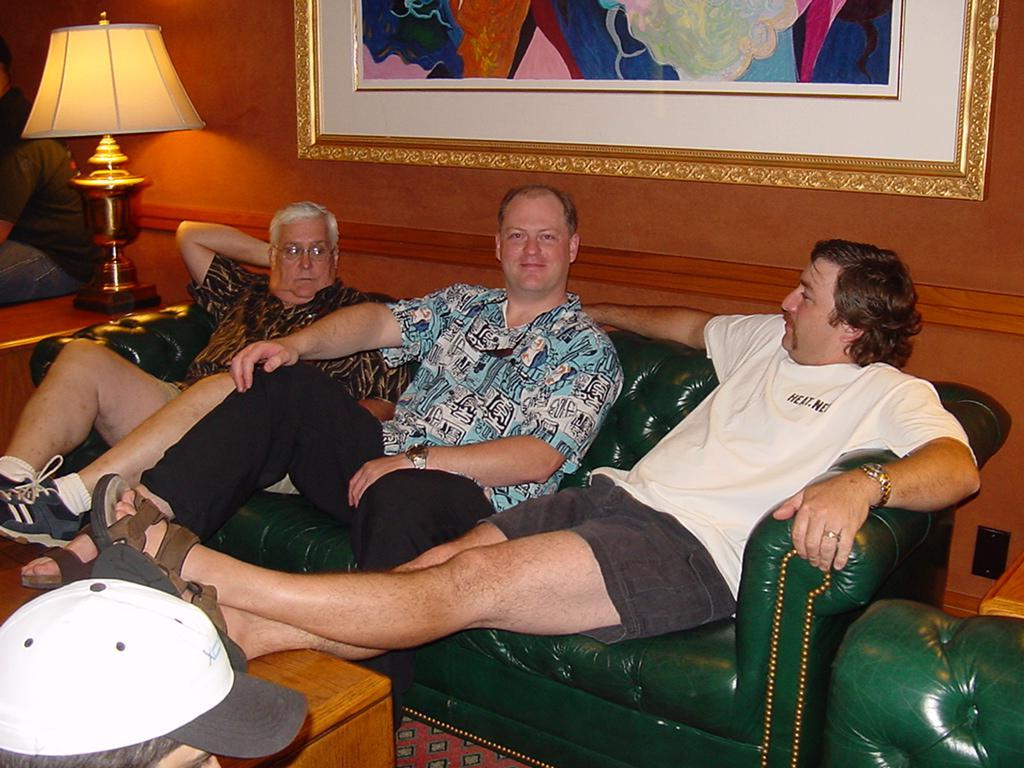How many people are in the image? There are three men in the image. What are the men doing in the image? The men are sitting on a sofa, and they have their legs on a table. What can be seen in the background of the image? There is a lamp and a frame on the wall in the background of the image. What is the name of the actor sitting on the left side of the sofa in the image? There is no actor present in the image, and we cannot determine the names of the individuals in the image. How many hands are visible in the image? The number of hands visible in the image cannot be determined from the provided facts. 